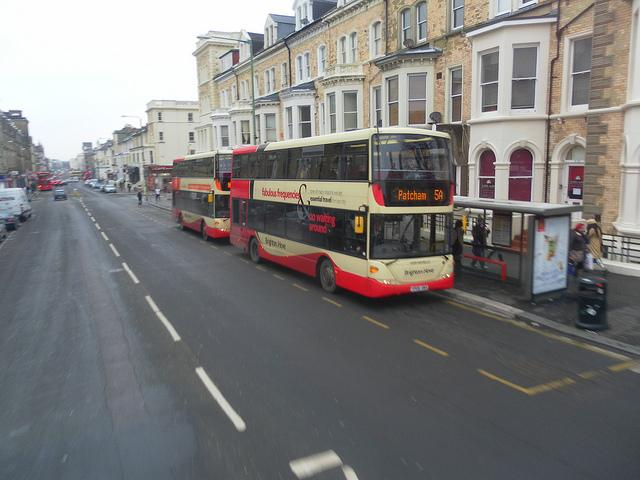When was the double-decker bus invented?

Choices:
A) 1910
B) 1893
C) 1900
D) 1906 1906 